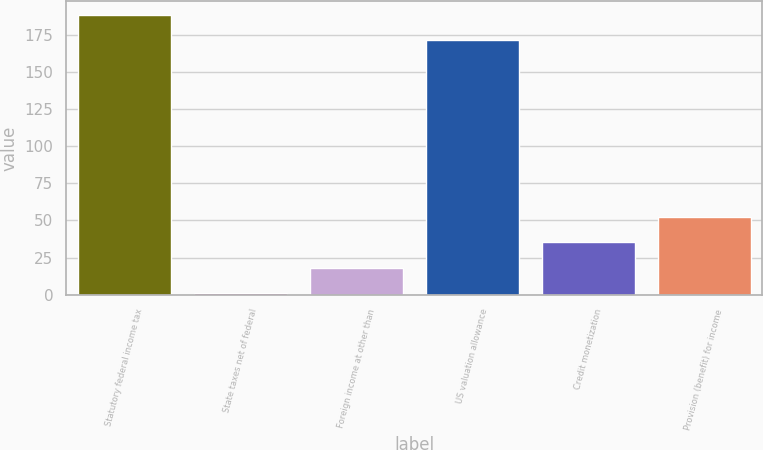Convert chart to OTSL. <chart><loc_0><loc_0><loc_500><loc_500><bar_chart><fcel>Statutory federal income tax<fcel>State taxes net of federal<fcel>Foreign income at other than<fcel>US valuation allowance<fcel>Credit monetization<fcel>Provision (benefit) for income<nl><fcel>188.1<fcel>1<fcel>18.1<fcel>171<fcel>35.2<fcel>52.3<nl></chart> 